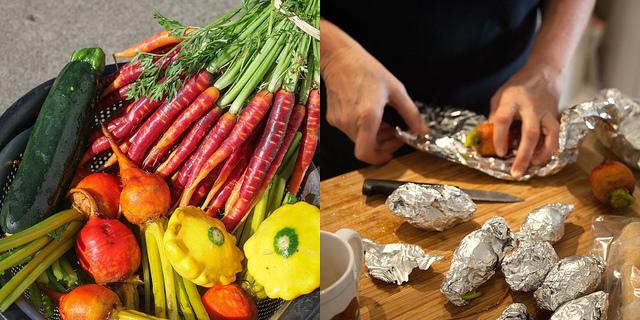What color is the table?
Short answer required. Brown. Are there separate pictures?
Answer briefly. Yes. What are the vegetables getting wrapped in?
Be succinct. Foil. 